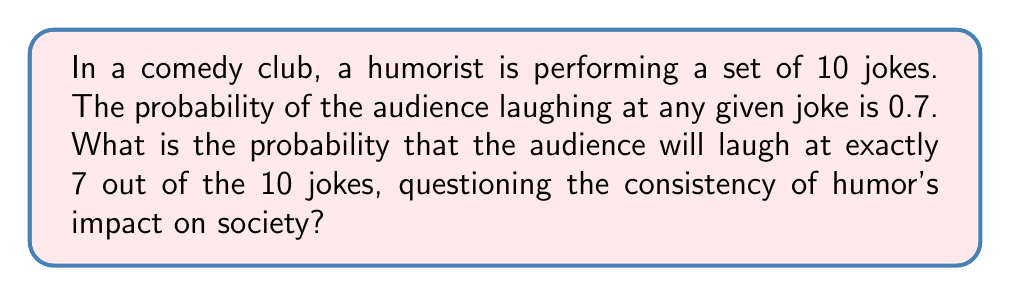Can you solve this math problem? To solve this problem, we'll use the binomial probability formula, as we're dealing with a fixed number of independent trials (jokes) with two possible outcomes (laugh or not laugh) for each trial.

1) The binomial probability formula is:

   $$ P(X = k) = \binom{n}{k} p^k (1-p)^{n-k} $$

   Where:
   $n$ = number of trials (jokes)
   $k$ = number of successes (jokes that get laughs)
   $p$ = probability of success on each trial

2) In this case:
   $n = 10$ (total jokes)
   $k = 7$ (jokes we want the audience to laugh at)
   $p = 0.7$ (probability of laughter for each joke)

3) Let's calculate the binomial coefficient $\binom{10}{7}$:

   $$ \binom{10}{7} = \frac{10!}{7!(10-7)!} = \frac{10!}{7!3!} = 120 $$

4) Now, let's plug everything into the formula:

   $$ P(X = 7) = 120 \cdot (0.7)^7 \cdot (1-0.7)^{10-7} $$

5) Simplify:
   $$ P(X = 7) = 120 \cdot (0.7)^7 \cdot (0.3)^3 $$

6) Calculate:
   $$ P(X = 7) \approx 120 \cdot 0.0824 \cdot 0.027 \approx 0.2668 $$

This probability showcases the variability in audience response, which might lead a humorist to question the consistency and importance of comedy in society.
Answer: $\approx 0.2668$ or $26.68\%$ 